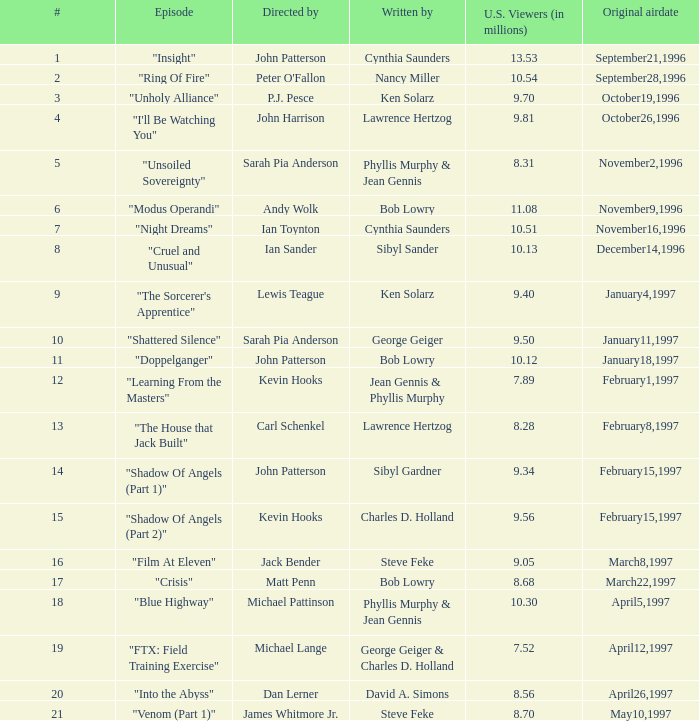What are the names of episodes numbered 19? "FTX: Field Training Exercise". 